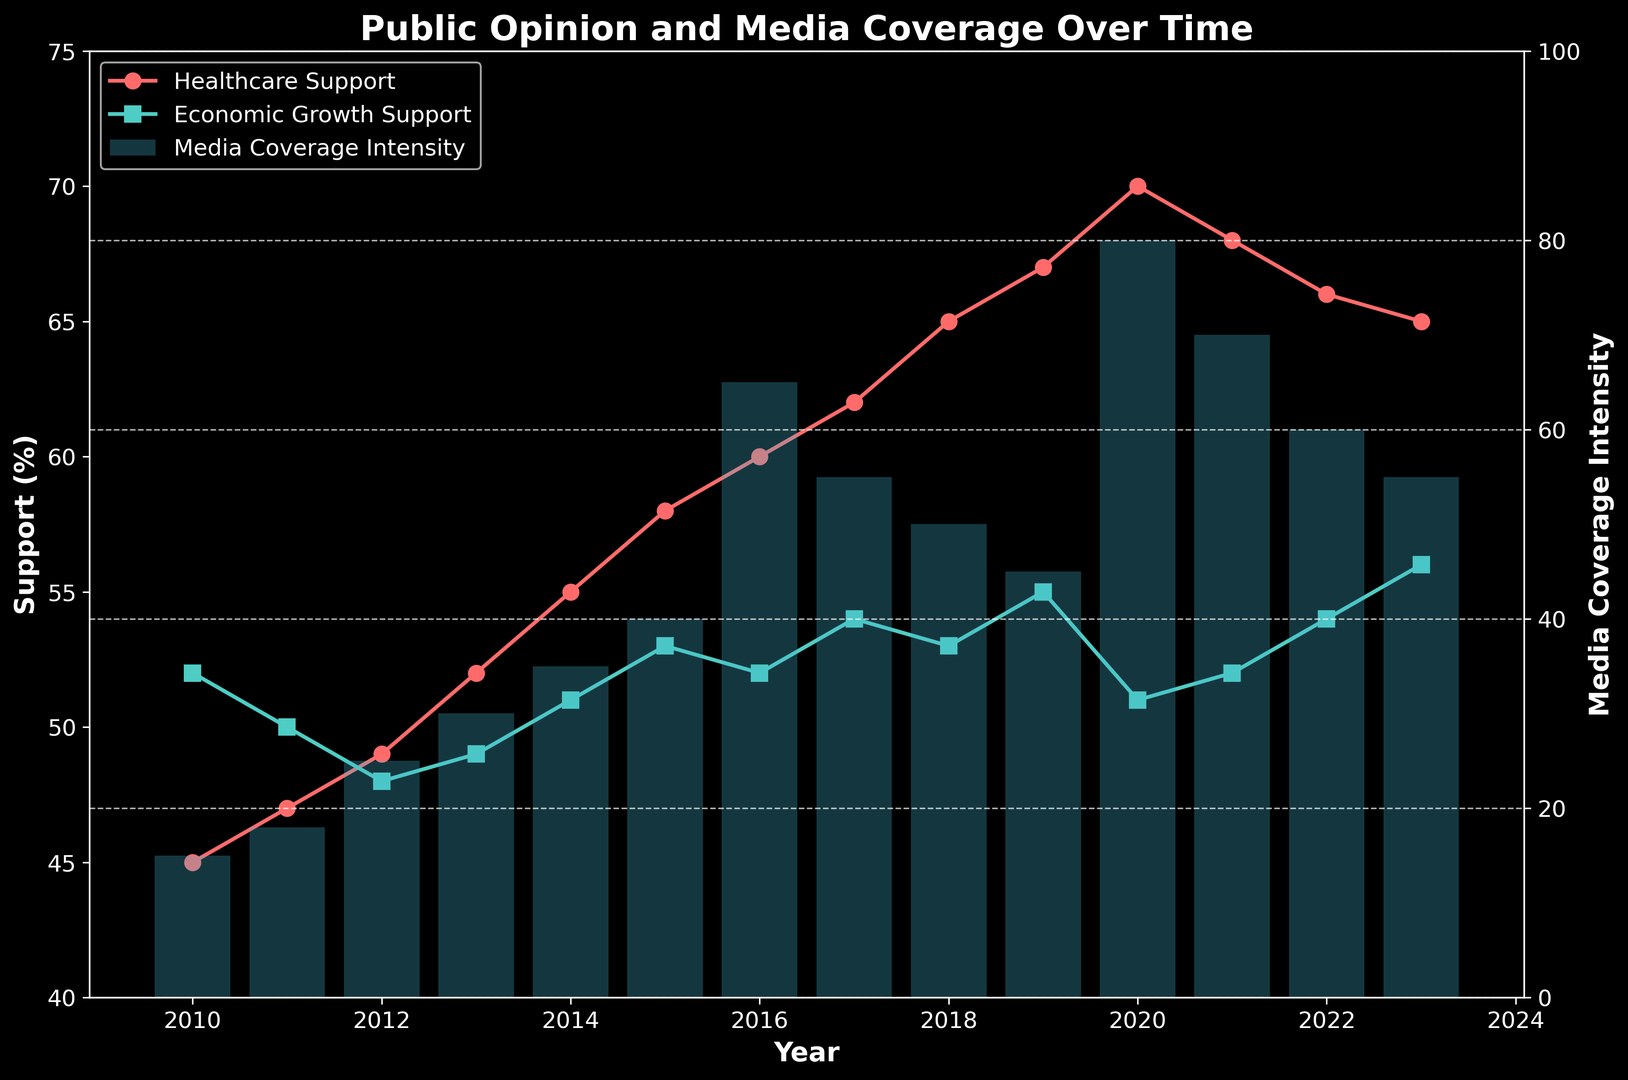What is the general trend of healthcare support from 2010 to 2023? By observing the plot, the red line representing healthcare support generally shows an upward trend from 2010 (45%) to 2023 (65%), indicating increasing support over time.
Answer: Increasing In which year did media coverage intensity peak, and what was the intensity value? The highest bar in the bar chart, which represents media coverage intensity, appears in 2020 with a value of 80.
Answer: 2020, 80 During which year did economic growth support and healthcare support first cross each other? The blue and teal lines representing healthcare support and economic growth support cross around the year 2015. Before 2015, economic growth support was higher than healthcare support, and after 2015, healthcare support was higher.
Answer: 2015 How did media coverage intensity change from 2016 to 2017, and by how much? The height of the bars indicates media coverage intensity. In 2016, it was 65, and in 2017, it was 55. The decrease is calculated as 65 - 55 = 10.
Answer: Decreased by 10 What is the average media coverage intensity from 2012 to 2014? Adding the values from 2012 (25), 2013 (30), and 2014 (35) gives 25 + 30 + 35 = 90. The average is 90 / 3 = 30.
Answer: 30 Which year saw the highest disparity between healthcare support and economic growth support, and what is the disparity value? To find the highest disparity, look for the year with the largest vertical distance between the red and teal lines. In 2020, healthcare support was 70%, and economic growth support was 51%, resulting in a disparity of 70 - 51 = 19.
Answer: 2020, 19 Which line represents healthcare support, and how can you tell? The red line represents healthcare support, as indicated by the legend and the colors used in the plot explanations.
Answer: Red line By how much did healthcare support change from 2019 to 2020? The red line shows healthcare support at 67% in 2019 and 70% in 2020. The change is 70 - 67 = 3.
Answer: Increased by 3 Compare media coverage intensity in 2014 and 2022. Observing the heights of the bars, media coverage intensity in 2014 was 35 and in 2022 it was 60. This indicates an increase.
Answer: Increased from 35 to 60 What was the general trend of economic growth support between 2010 and 2023? The teal line representing economic growth support shows minor fluctuations but maintains a fairly stable range between 48% and 56% over this period.
Answer: Stable with minor fluctuations 